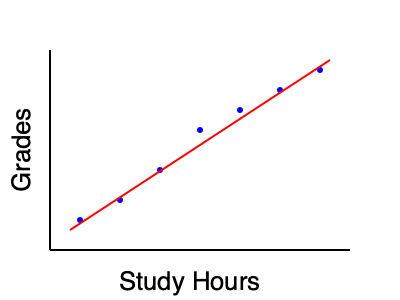As a school principal collaborating with an entrepreneur to provide academic support, you're analyzing the relationship between study hours and grades. Based on the scatter plot provided, what can you conclude about the correlation between study hours and grades, and how might this information inform your academic support strategies? To analyze the correlation between study hours and grades using the scatter plot, we'll follow these steps:

1. Observe the overall pattern:
   The points in the scatter plot show a clear upward trend from left to right.

2. Assess the strength of the relationship:
   The points form a relatively tight pattern around an imaginary straight line, indicating a strong relationship.

3. Determine the direction of the correlation:
   As study hours increase (moving right on the x-axis), grades tend to increase (moving up on the y-axis), suggesting a positive correlation.

4. Estimate the linearity:
   The points appear to follow a roughly linear pattern, as indicated by the red trend line.

5. Look for outliers:
   There are no obvious outliers in this scatter plot that deviate significantly from the overall pattern.

6. Interpret the correlation:
   There is a strong positive linear correlation between study hours and grades.

7. Consider implications for academic support strategies:
   a. Encourage students to increase study time, as it's associated with higher grades.
   b. Develop programs to help students manage their study time effectively.
   c. Create supportive study environments or after-school programs.
   d. Educate parents on the importance of dedicated study time.
   e. Monitor and track students' study habits and grades to provide targeted support.

8. Remember limitations:
   Correlation does not imply causation. Other factors may influence grades, and individual students may have different optimal study strategies.
Answer: Strong positive linear correlation between study hours and grades; implement strategies to increase and optimize study time. 